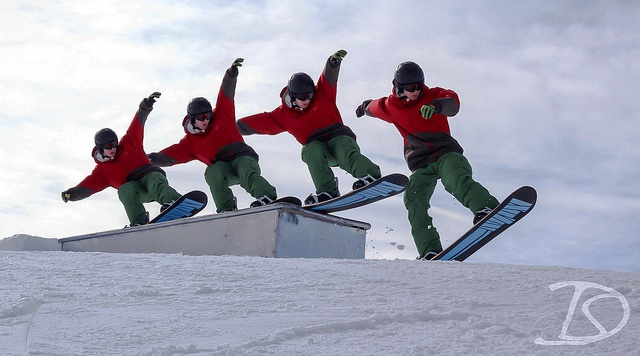Describe the objects in this image and their specific colors. I can see people in white, black, maroon, darkgreen, and brown tones, people in white, black, maroon, darkgreen, and gray tones, people in white, black, maroon, and lightgray tones, people in white, black, and maroon tones, and snowboard in white, black, gray, and blue tones in this image. 